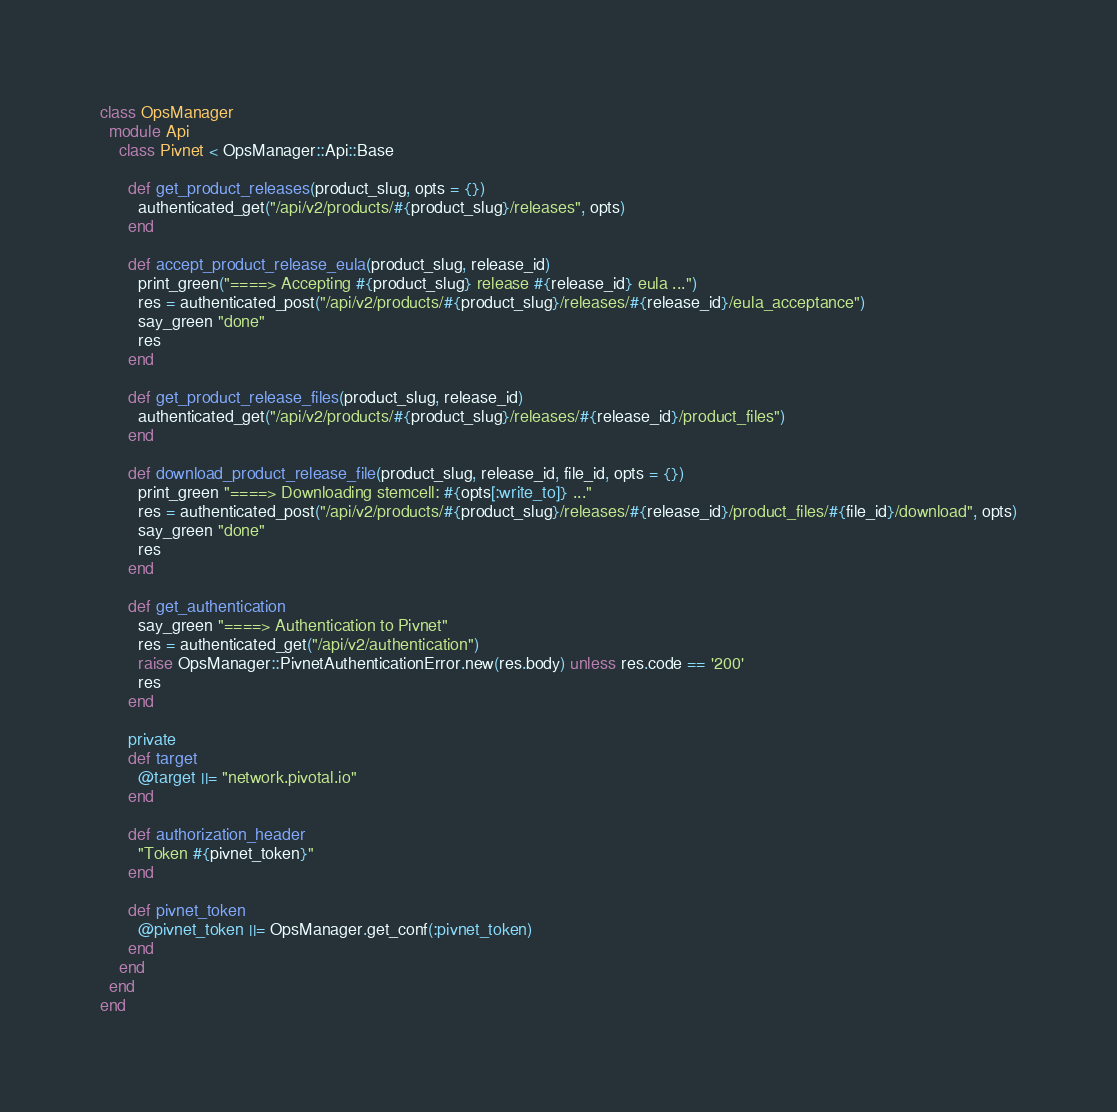<code> <loc_0><loc_0><loc_500><loc_500><_Ruby_>class OpsManager
  module Api
    class Pivnet < OpsManager::Api::Base

      def get_product_releases(product_slug, opts = {})
        authenticated_get("/api/v2/products/#{product_slug}/releases", opts)
      end

      def accept_product_release_eula(product_slug, release_id)
        print_green("====> Accepting #{product_slug} release #{release_id} eula ...")
        res = authenticated_post("/api/v2/products/#{product_slug}/releases/#{release_id}/eula_acceptance")
        say_green "done"
        res
      end

      def get_product_release_files(product_slug, release_id)
        authenticated_get("/api/v2/products/#{product_slug}/releases/#{release_id}/product_files")
      end

      def download_product_release_file(product_slug, release_id, file_id, opts = {})
        print_green "====> Downloading stemcell: #{opts[:write_to]} ..."
        res = authenticated_post("/api/v2/products/#{product_slug}/releases/#{release_id}/product_files/#{file_id}/download", opts)
        say_green "done"
        res
      end

      def get_authentication
        say_green "====> Authentication to Pivnet"
        res = authenticated_get("/api/v2/authentication")
        raise OpsManager::PivnetAuthenticationError.new(res.body) unless res.code == '200'
        res
      end

      private
      def target
        @target ||= "network.pivotal.io"
      end

      def authorization_header
        "Token #{pivnet_token}"
      end

      def pivnet_token
        @pivnet_token ||= OpsManager.get_conf(:pivnet_token)
      end
    end
  end
end
</code> 